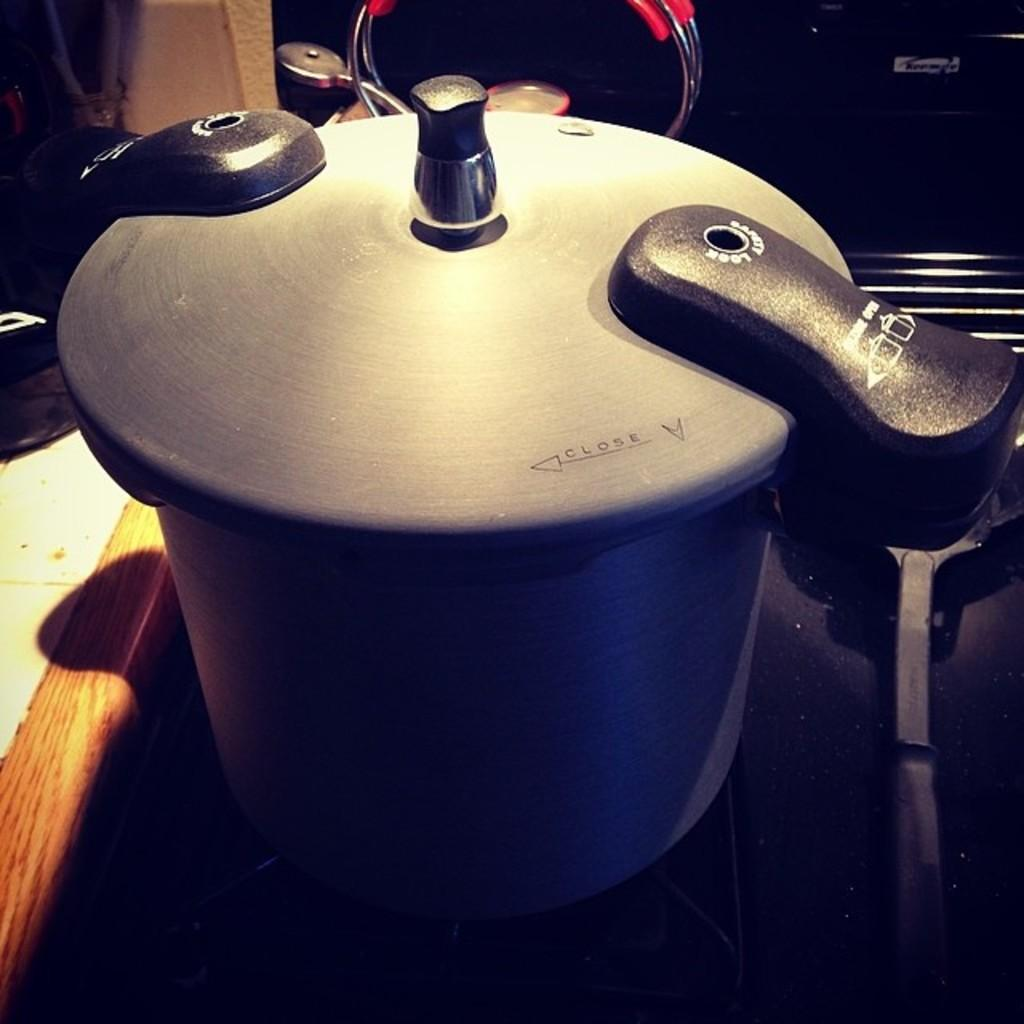Provide a one-sentence caption for the provided image. The lid of a pot has to be turned clockwise in order to close correctly. 